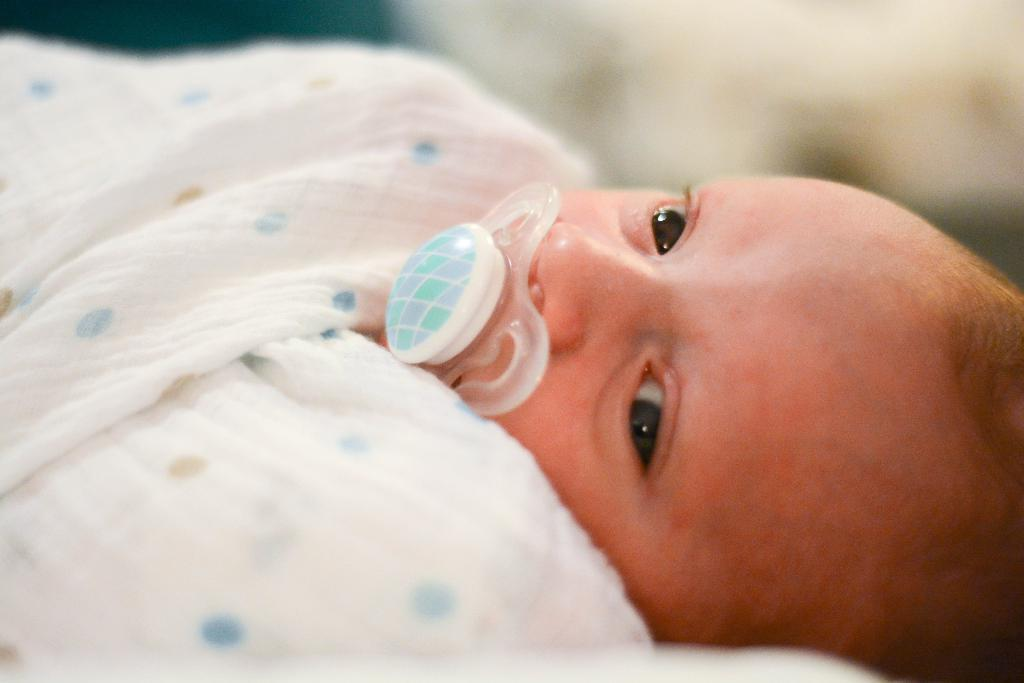What is the main subject of the image? There is a baby in the image. What is the baby's position in the image? The baby is lying down. What is the baby wearing? The baby is wearing cloth. What object is in the baby's mouth? There is a soother in the baby's mouth. What type of texture can be seen on the baby's nose in the image? There is no specific texture visible on the baby's nose in the image. 